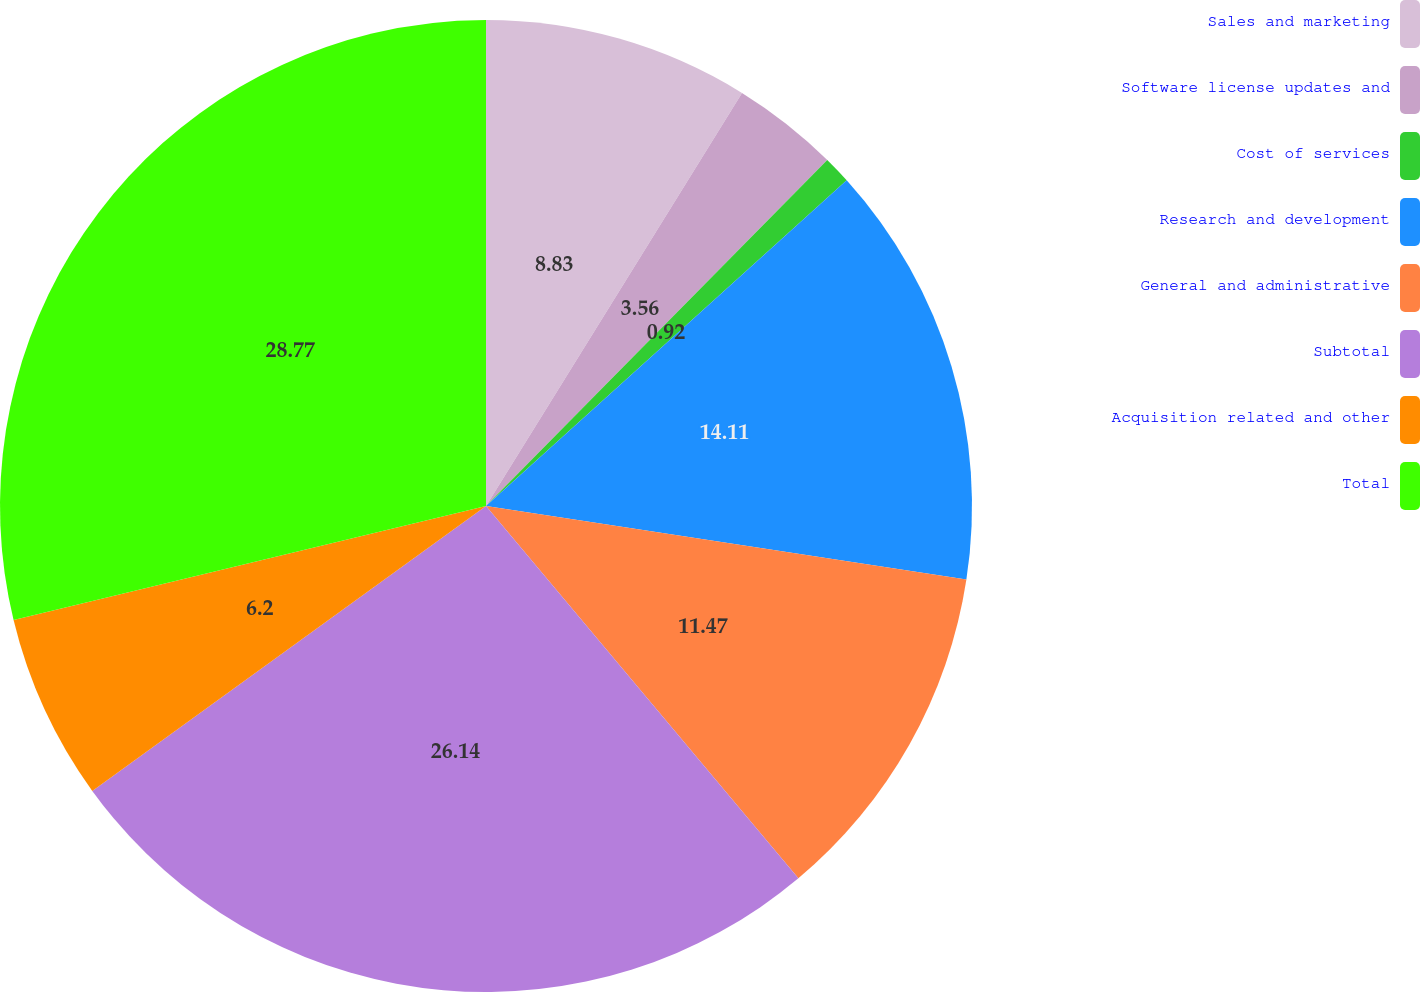Convert chart. <chart><loc_0><loc_0><loc_500><loc_500><pie_chart><fcel>Sales and marketing<fcel>Software license updates and<fcel>Cost of services<fcel>Research and development<fcel>General and administrative<fcel>Subtotal<fcel>Acquisition related and other<fcel>Total<nl><fcel>8.83%<fcel>3.56%<fcel>0.92%<fcel>14.11%<fcel>11.47%<fcel>26.14%<fcel>6.2%<fcel>28.77%<nl></chart> 